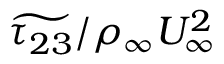Convert formula to latex. <formula><loc_0><loc_0><loc_500><loc_500>\widetilde { \tau _ { 2 3 } } / \rho _ { \infty } U _ { \infty } ^ { 2 }</formula> 